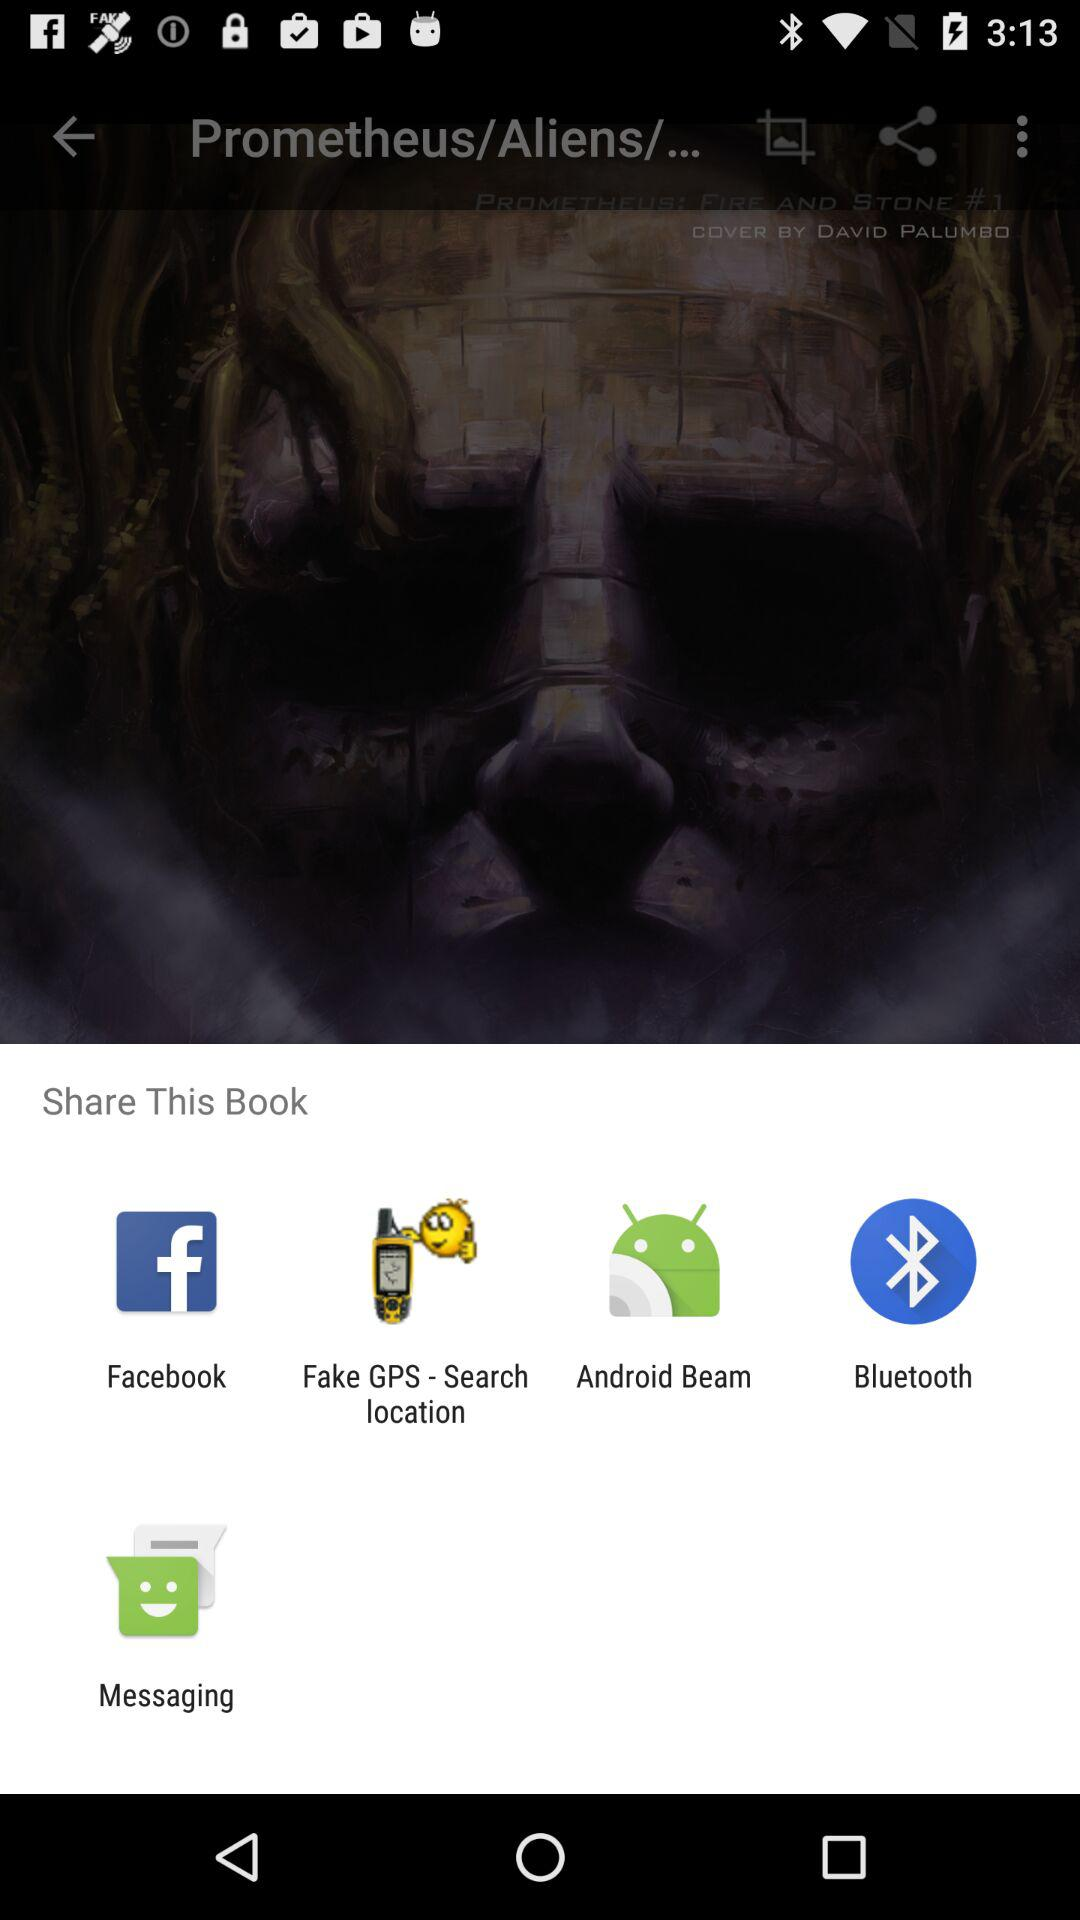What are the different options through which we can share the book? The different options through which you can share the book are "Facebook", "Fake GPS - Search location", "Android Beam", "Bluetooth" and "Messaging". 